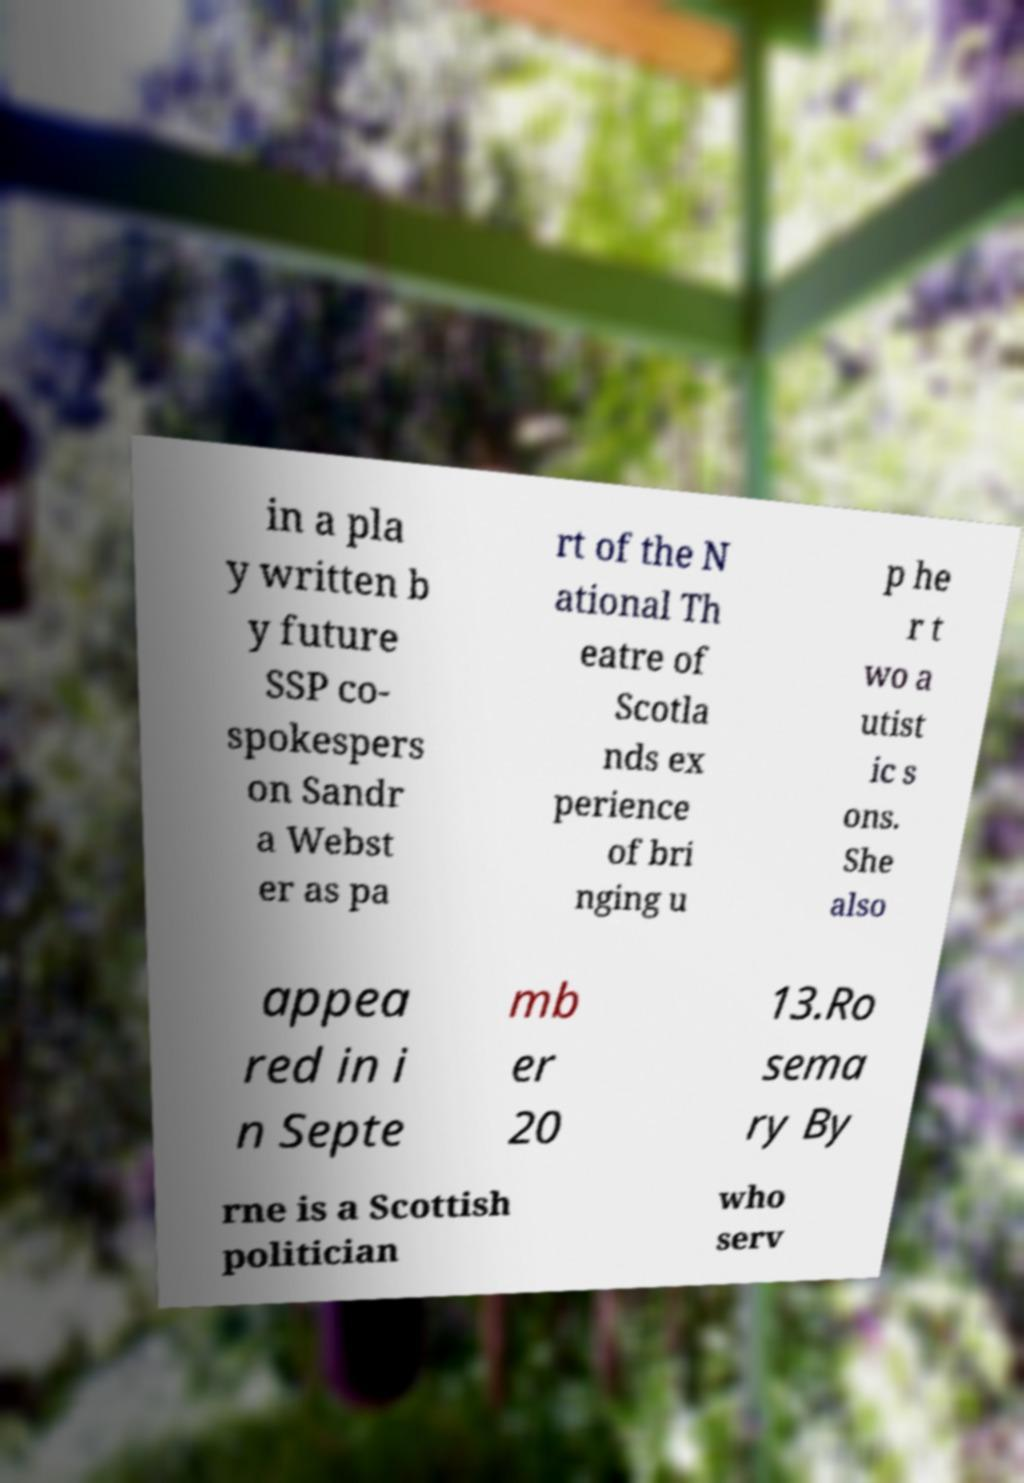Please identify and transcribe the text found in this image. in a pla y written b y future SSP co- spokespers on Sandr a Webst er as pa rt of the N ational Th eatre of Scotla nds ex perience of bri nging u p he r t wo a utist ic s ons. She also appea red in i n Septe mb er 20 13.Ro sema ry By rne is a Scottish politician who serv 